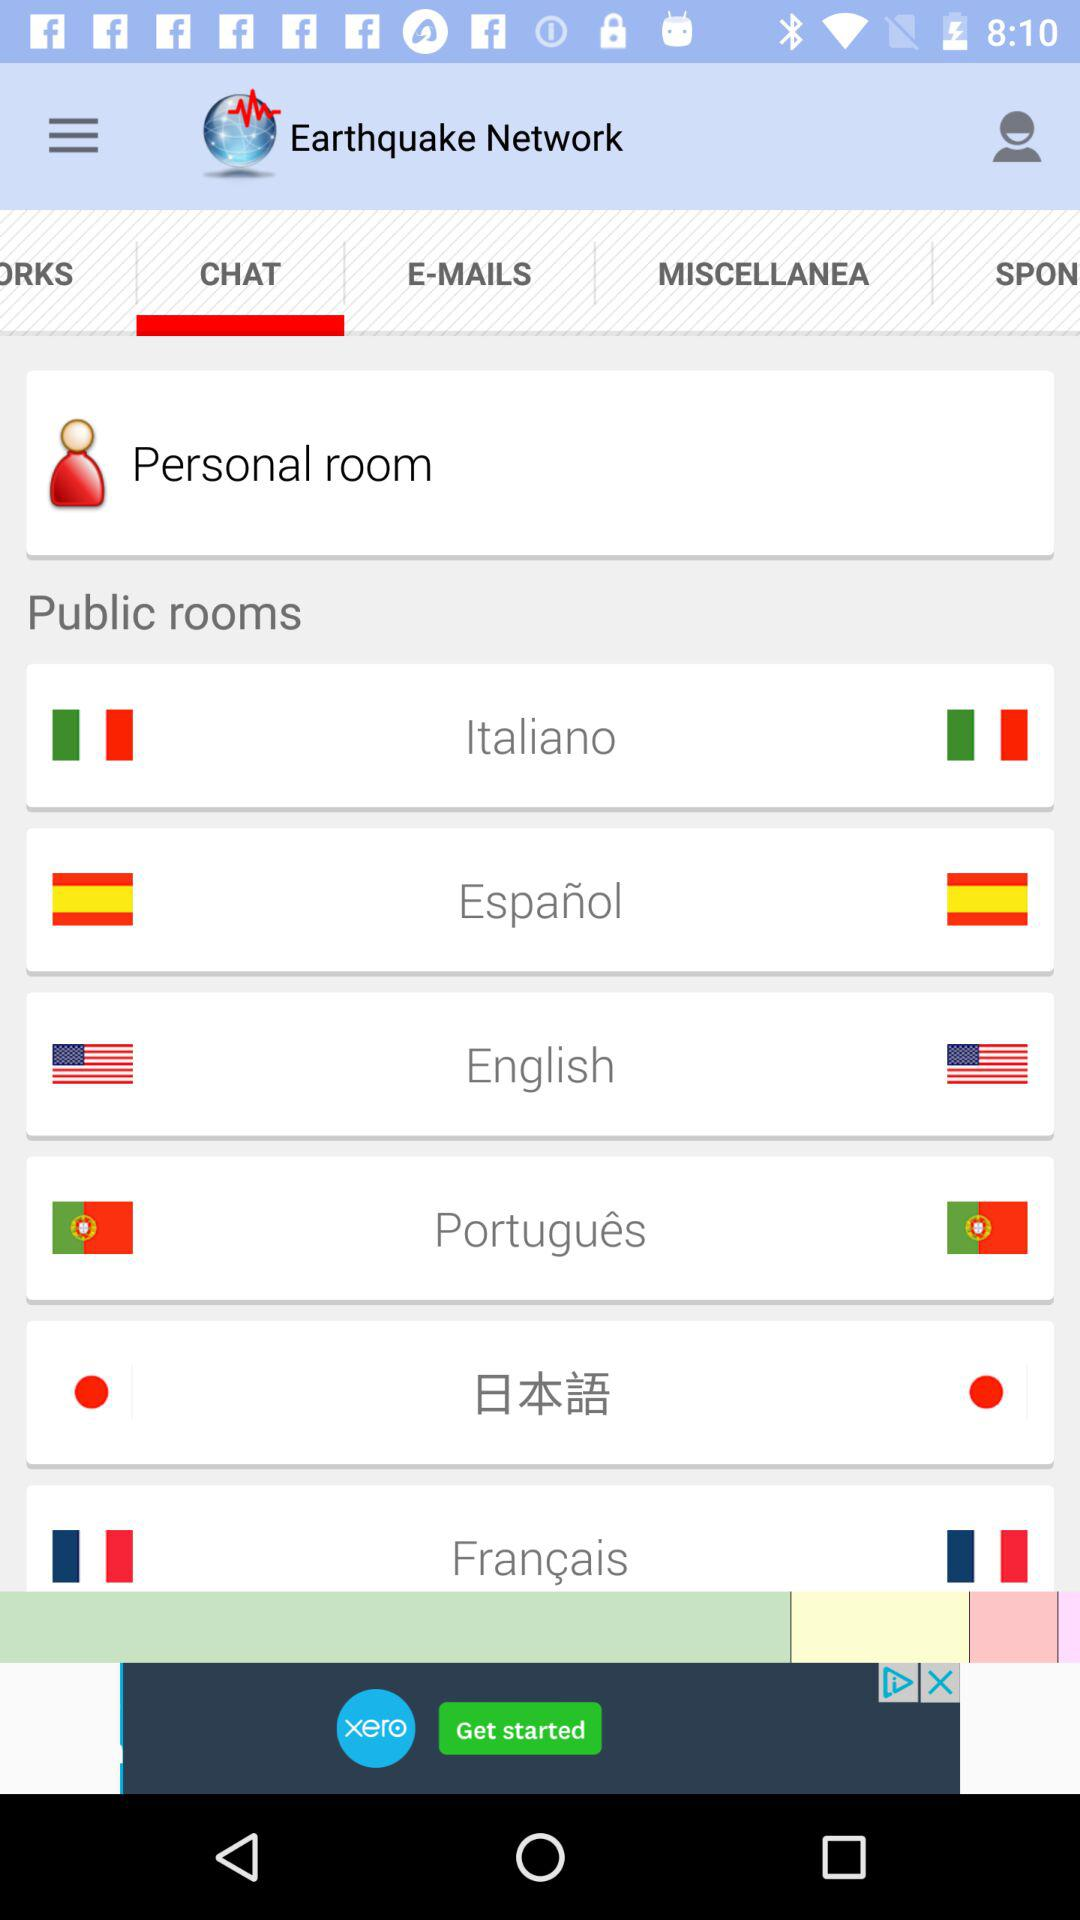What is the name of the application? The name of the application is "Earthquake Network". 